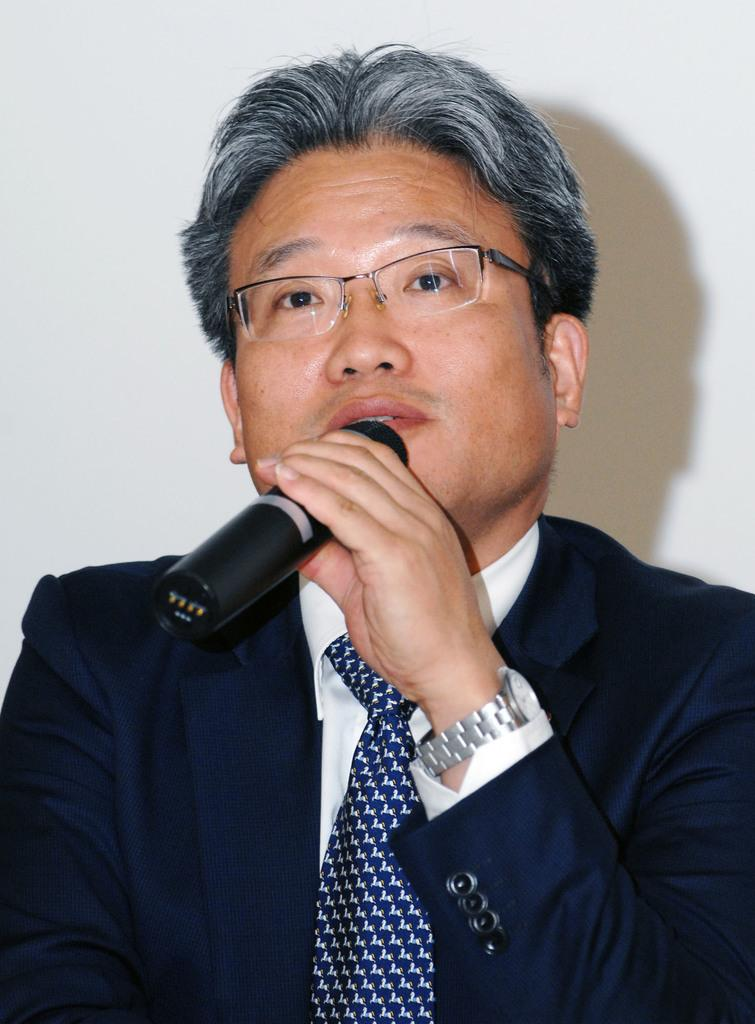What is present in the image? There is a man in the image. What is the man holding in his hands? The man is holding a microphone in his hands. What size books is the man reading in the image? There are no books present in the image, and the man is holding a microphone instead. 